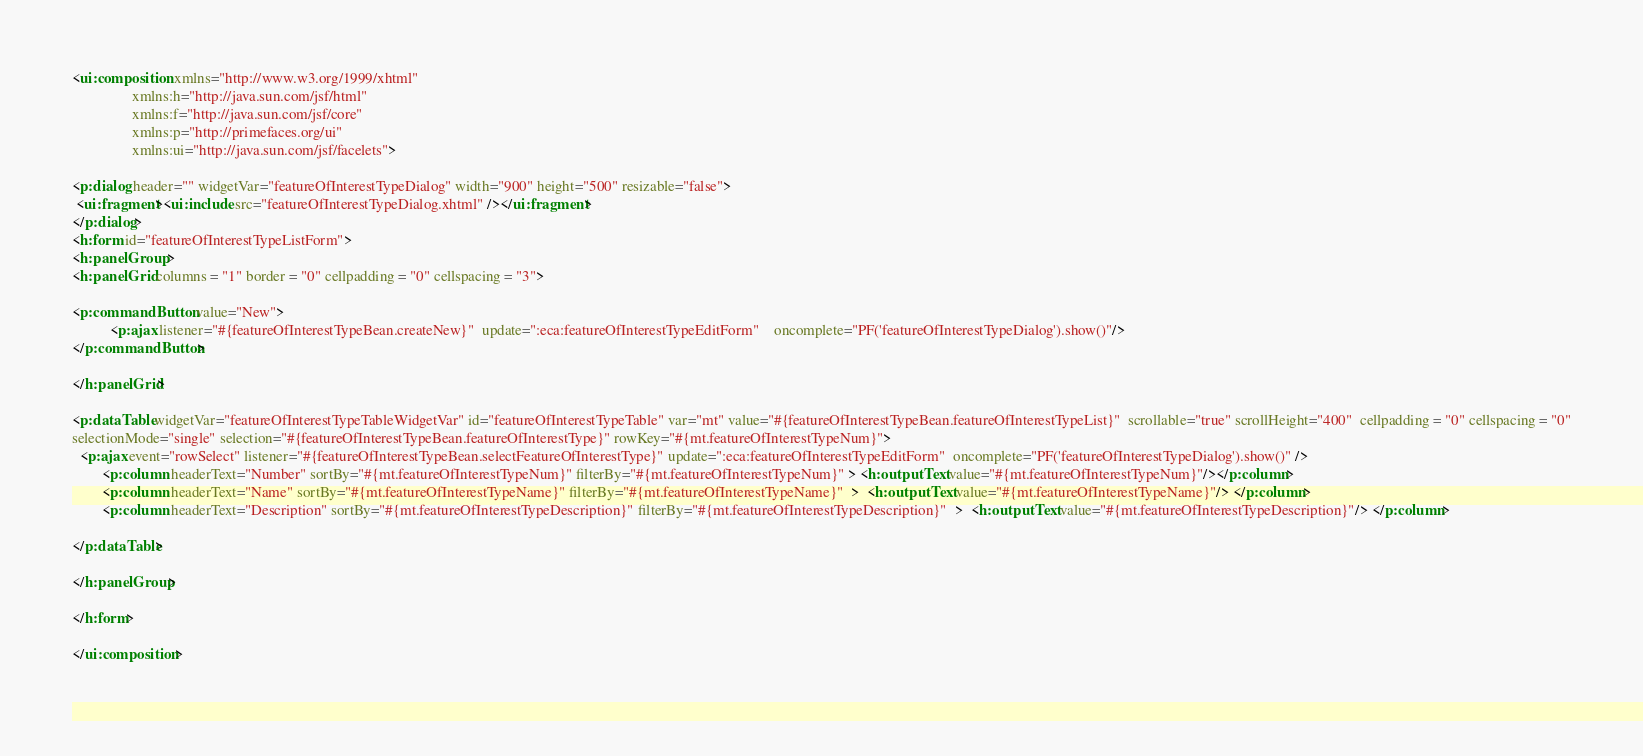Convert code to text. <code><loc_0><loc_0><loc_500><loc_500><_HTML_>
<ui:composition xmlns="http://www.w3.org/1999/xhtml"
                xmlns:h="http://java.sun.com/jsf/html"
                xmlns:f="http://java.sun.com/jsf/core"
                xmlns:p="http://primefaces.org/ui"
                xmlns:ui="http://java.sun.com/jsf/facelets"> 

<p:dialog header="" widgetVar="featureOfInterestTypeDialog" width="900" height="500" resizable="false"> 
 <ui:fragment><ui:include src="featureOfInterestTypeDialog.xhtml" /></ui:fragment>
</p:dialog>
<h:form id="featureOfInterestTypeListForm">
<h:panelGroup >
<h:panelGrid columns = "1" border = "0" cellpadding = "0" cellspacing = "3">
  
<p:commandButton value="New">
		  <p:ajax listener="#{featureOfInterestTypeBean.createNew}"  update=":eca:featureOfInterestTypeEditForm"    oncomplete="PF('featureOfInterestTypeDialog').show()"/>
</p:commandButton>

</h:panelGrid>

<p:dataTable widgetVar="featureOfInterestTypeTableWidgetVar" id="featureOfInterestTypeTable" var="mt" value="#{featureOfInterestTypeBean.featureOfInterestTypeList}"  scrollable="true" scrollHeight="400"  cellpadding = "0" cellspacing = "0"
selectionMode="single" selection="#{featureOfInterestTypeBean.featureOfInterestType}" rowKey="#{mt.featureOfInterestTypeNum}">  	
  <p:ajax event="rowSelect" listener="#{featureOfInterestTypeBean.selectFeatureOfInterestType}" update=":eca:featureOfInterestTypeEditForm"  oncomplete="PF('featureOfInterestTypeDialog').show()" /> 
  		<p:column headerText="Number" sortBy="#{mt.featureOfInterestTypeNum}" filterBy="#{mt.featureOfInterestTypeNum}" > <h:outputText value="#{mt.featureOfInterestTypeNum}"/></p:column>
 		<p:column headerText="Name" sortBy="#{mt.featureOfInterestTypeName}" filterBy="#{mt.featureOfInterestTypeName}"  >  <h:outputText value="#{mt.featureOfInterestTypeName}"/> </p:column>
    	<p:column headerText="Description" sortBy="#{mt.featureOfInterestTypeDescription}" filterBy="#{mt.featureOfInterestTypeDescription}"  >  <h:outputText value="#{mt.featureOfInterestTypeDescription}"/> </p:column>
    
</p:dataTable>	

</h:panelGroup>

</h:form>

</ui:composition>
 </code> 